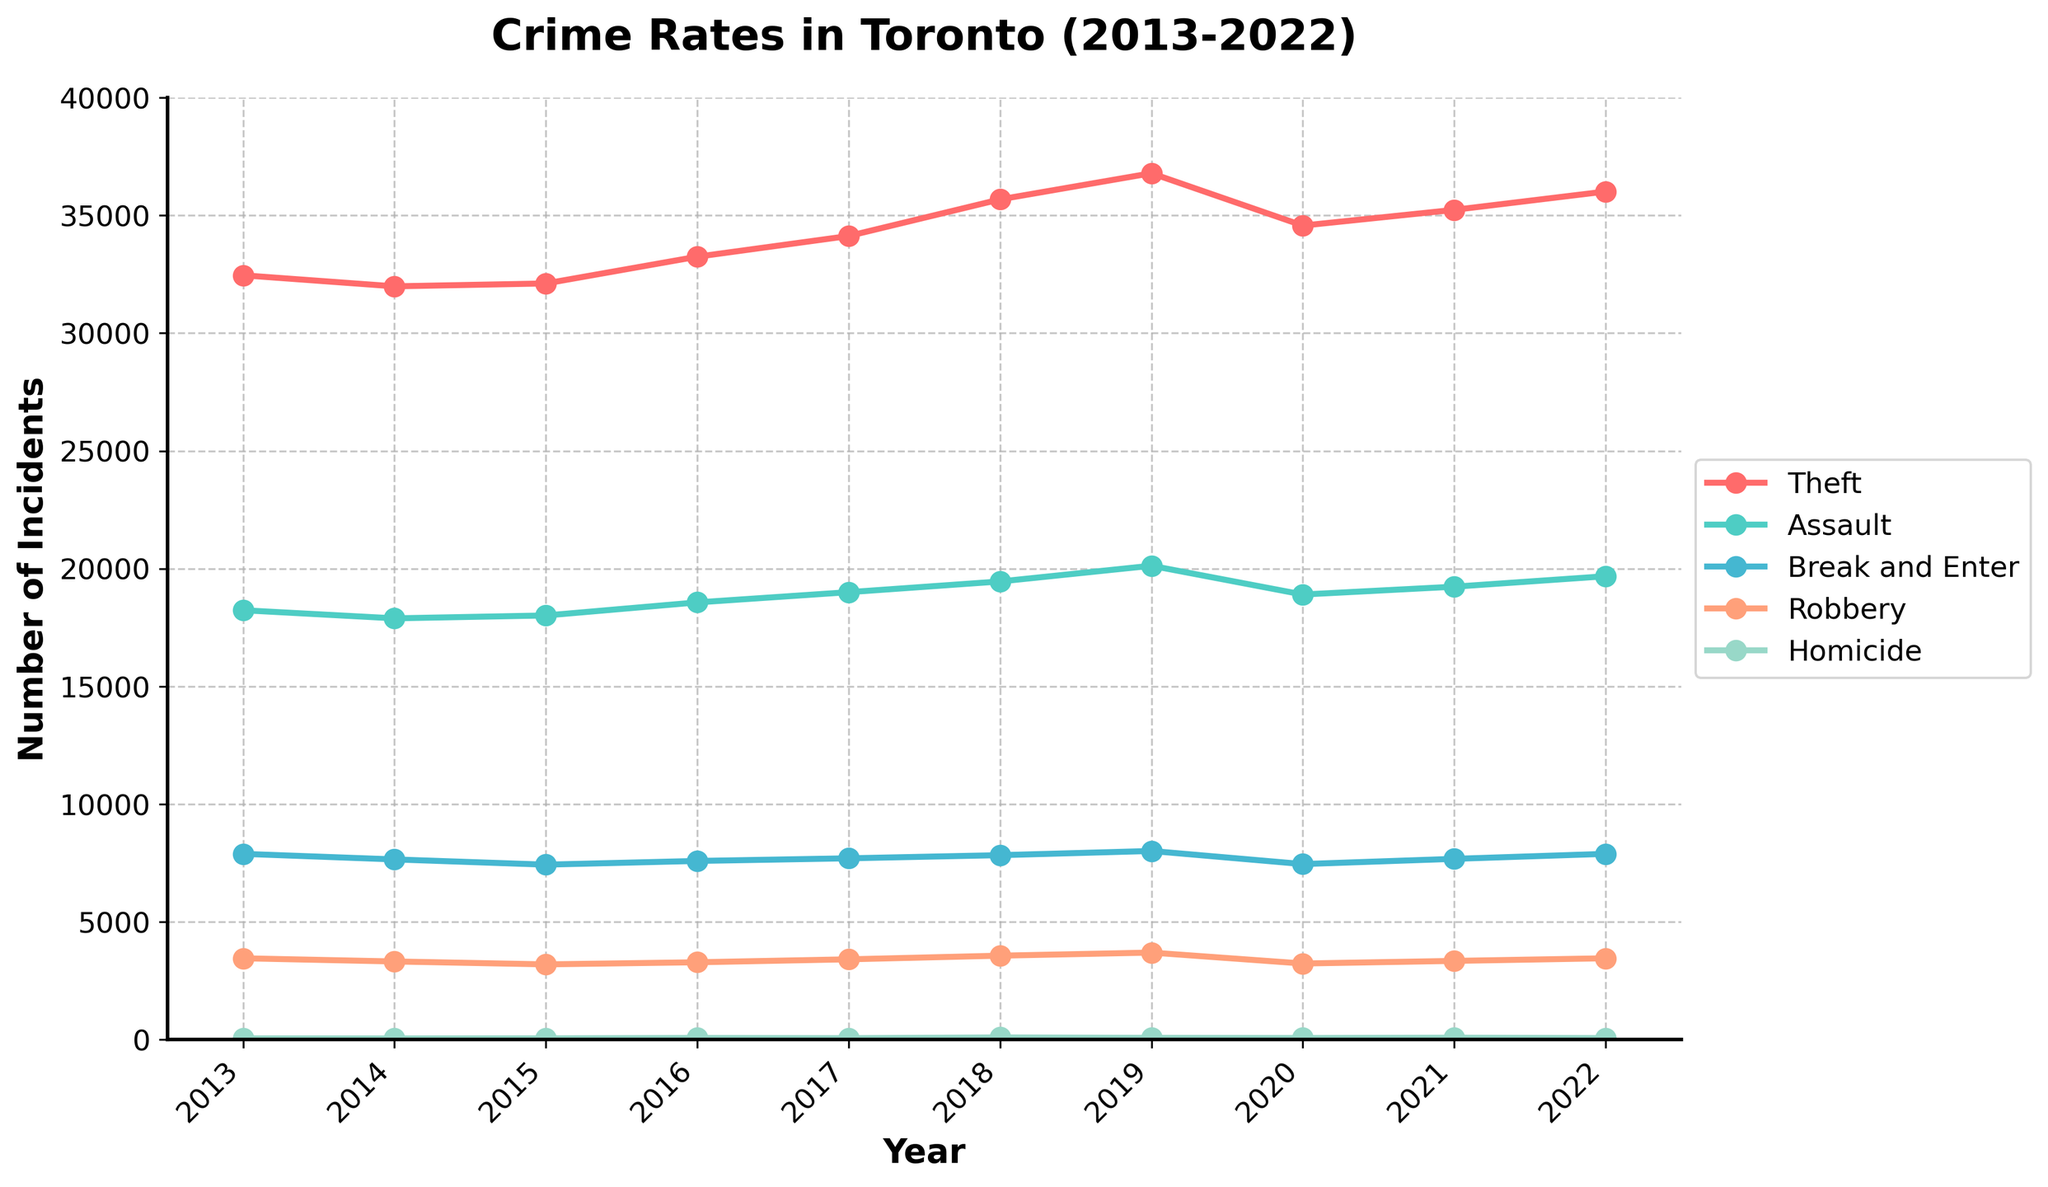What's the trend in the number of theft incidents from 2013 to 2022? To identify the trend, look at how the line representing theft on the chart moves over time. Notice it starts at around 32,456 in 2013 and increases overall to 36,012 in 2022. It shows an upward trend.
Answer: Upward trend Which year had the highest number of homicide incidents? Observe the line representing homicides on the chart and find the peak point. The highest point is in 2018 with 96 incidents.
Answer: 2018 How do the robbery incidents in 2016 compare to those in 2022? Look at the lines for robbery in 2016 and 2022. In 2016, there were 3,287 incidents, whereas, in 2022, there were 3,456. Robbery incidents increased.
Answer: Increased What is the difference in the number of assault incidents between 2015 and 2020? Find the assault incidents for 2015 and 2020. In 2015, it was 18,012 while in 2020, it was 18,901. The difference is 18,901 - 18,012 = 889.
Answer: 889 Which type of offense saw the most significant increase from 2013 to 2022? To determine the most significant increase, compare the starting and ending points for each offense on the chart from 2013 to 2022. Theft saw an increase from 32,456 to 36,012, which is 3,556. All other offenses increased by a lower number of incidents.
Answer: Theft What's the average number of Break and Enter incidents over the decade? Add all the incident numbers for Break and Enter (7,890 + 7,654 + 7,432 + 7,589 + 7,701 + 7,834 + 8,012 + 7,456 + 7,678 + 7,890) and divide by 10. The sum is 77,136, so the average is 77,136 / 10 = 7,713.6
Answer: 7,713.6 Did any type of offense show a declining trend? Observe the trajectories for each offense. All offense types show an upward or fluctuating trend, with no clear downward trend over the decade.
Answer: No What colors represent Theft and Assault in the figure? Identify the lines' colors on the chart. Theft is represented by red and Assault by turquoise.
Answer: Theft (red), Assault (turquoise) Which type of offense has the least number of incidents each year? Examine each year's data to find the offense with the lowest data points consistently. Homicide has the least number of incidents every year.
Answer: Homicide What's the sum of Assault and Robbery incidents in 2019? Add the numbers for Assault (20,123) and Robbery (3,698) in 2019. The sum is 20,123 + 3,698 = 23,821.
Answer: 23,821 